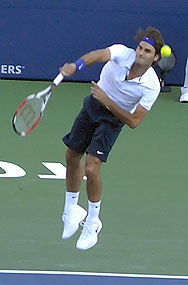Describe the objects in this image and their specific colors. I can see people in darkblue, white, black, gray, and darkgray tones, tennis racket in darkblue, gray, and darkgray tones, and sports ball in darkblue, yellow, and olive tones in this image. 